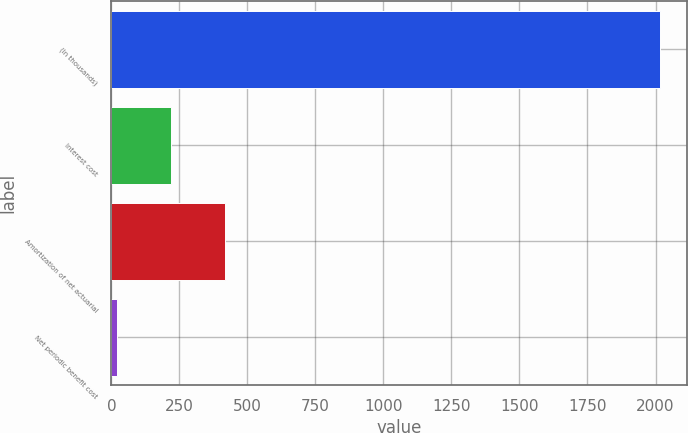Convert chart. <chart><loc_0><loc_0><loc_500><loc_500><bar_chart><fcel>(In thousands)<fcel>Interest cost<fcel>Amortization of net actuarial<fcel>Net periodic benefit cost<nl><fcel>2015<fcel>219.5<fcel>419<fcel>20<nl></chart> 